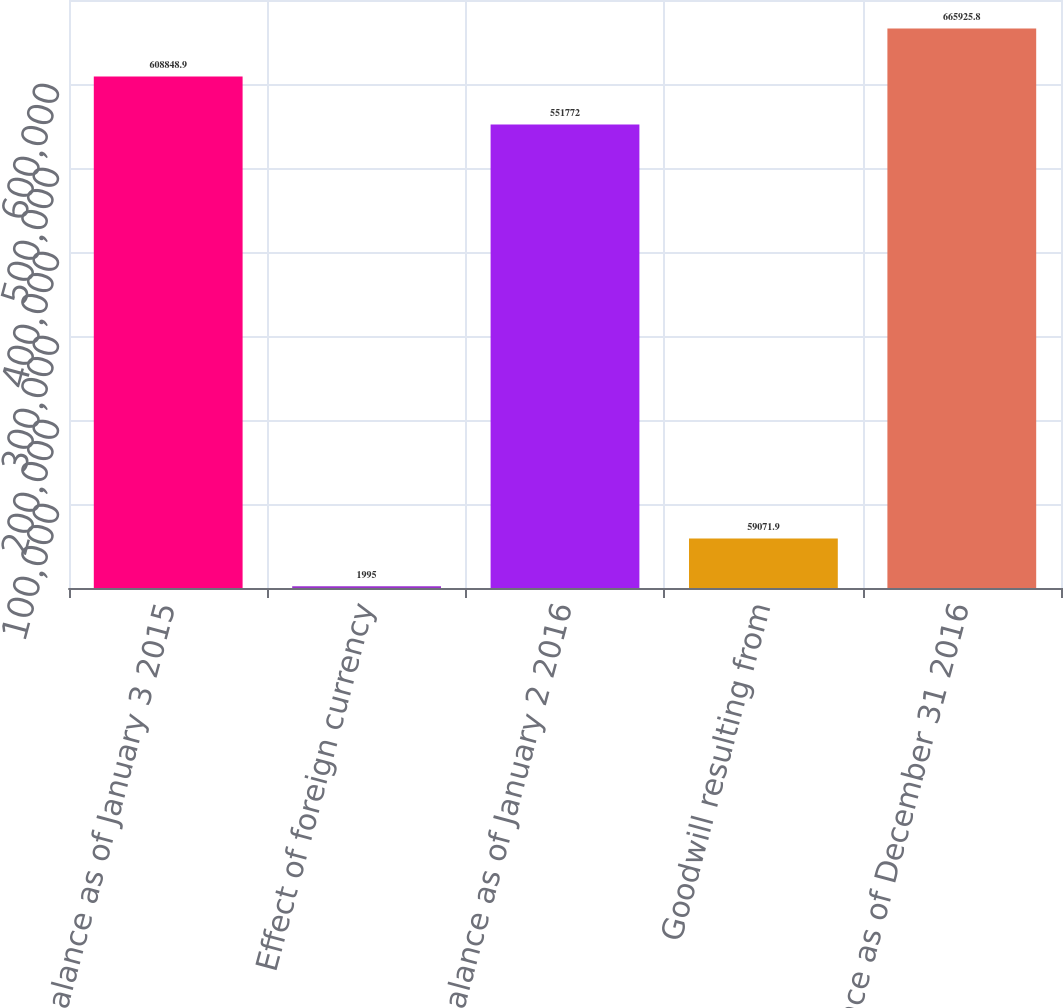Convert chart. <chart><loc_0><loc_0><loc_500><loc_500><bar_chart><fcel>Balance as of January 3 2015<fcel>Effect of foreign currency<fcel>Balance as of January 2 2016<fcel>Goodwill resulting from<fcel>Balance as of December 31 2016<nl><fcel>608849<fcel>1995<fcel>551772<fcel>59071.9<fcel>665926<nl></chart> 